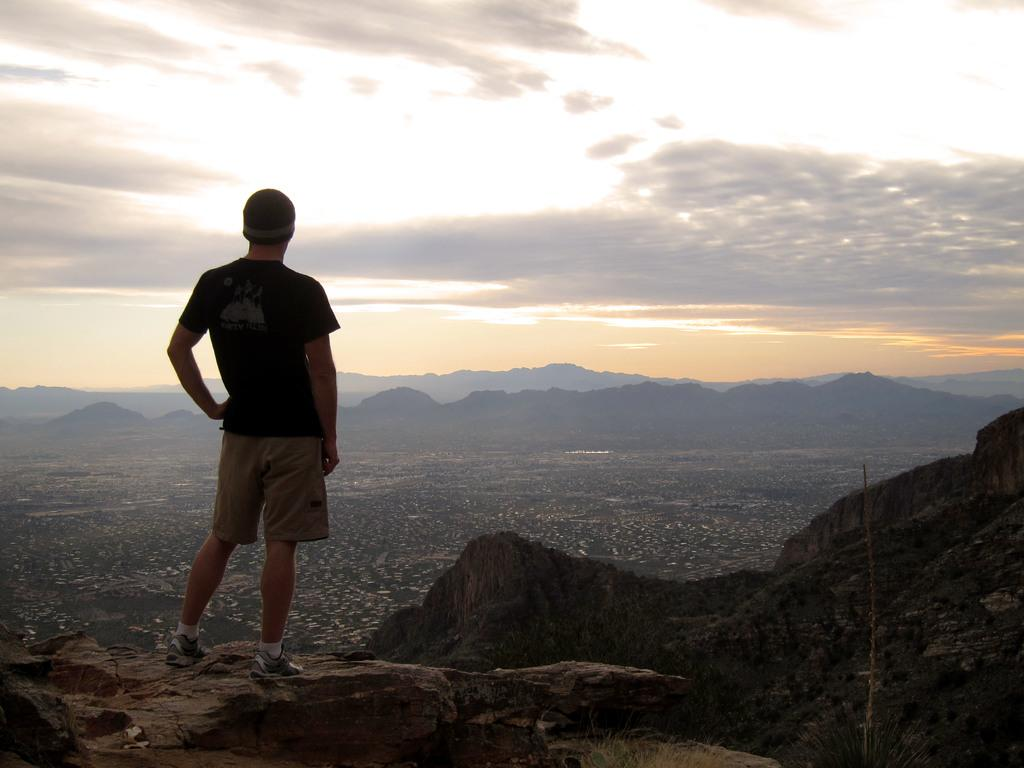Who is on the left side of the image? There is a man on the left side of the image. What is the man doing in the image? The man is standing in the image. What can be seen in the background of the image? Hills and clouds are visible in the background of the image. What type of beef is being cooked on the pot in the image? There is no pot or beef present in the image. How many boys are visible in the image? There are no boys visible in the image; only a man is present. 